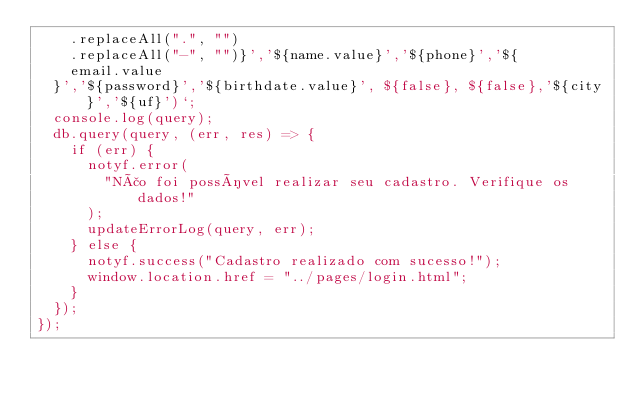Convert code to text. <code><loc_0><loc_0><loc_500><loc_500><_JavaScript_>    .replaceAll(".", "")
    .replaceAll("-", "")}','${name.value}','${phone}','${
    email.value
  }','${password}','${birthdate.value}', ${false}, ${false},'${city}','${uf}')`;
  console.log(query);
  db.query(query, (err, res) => {
    if (err) {
      notyf.error(
        "Não foi possível realizar seu cadastro. Verifique os dados!"
      );
      updateErrorLog(query, err);
    } else {
      notyf.success("Cadastro realizado com sucesso!");
      window.location.href = "../pages/login.html";
    }
  });
});
</code> 